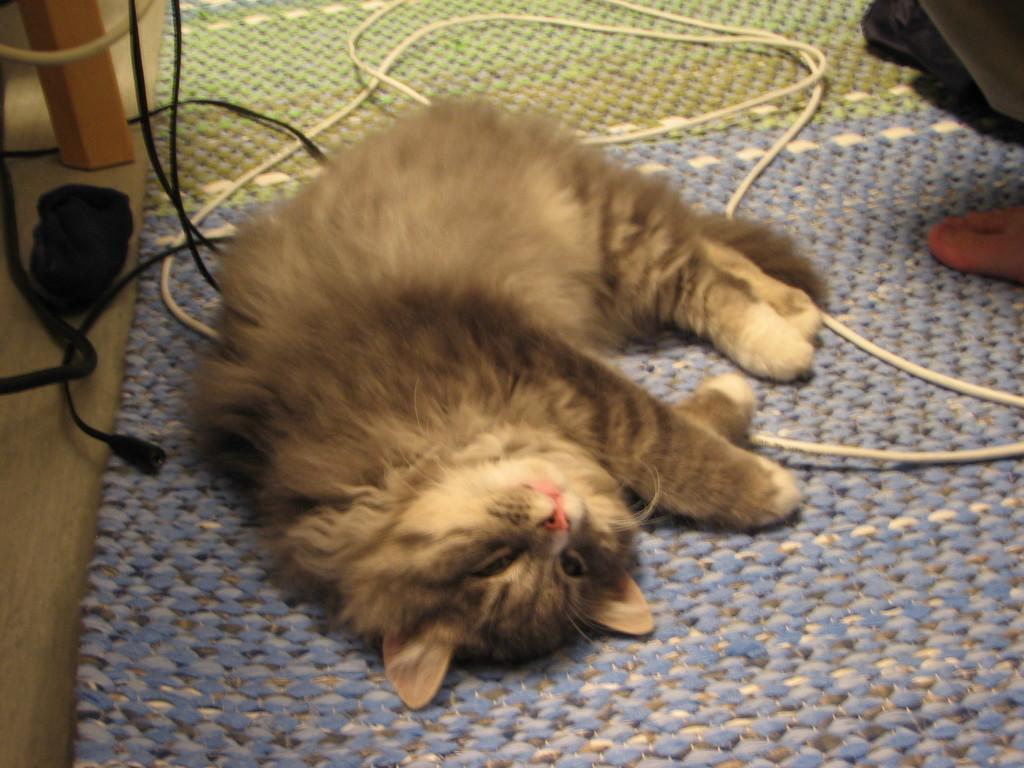Can you describe this image briefly? Here I can see a cat is laying on a mat and also there few cables. On the right side, I can see a person's foot. On the left side there is a wooden object. 